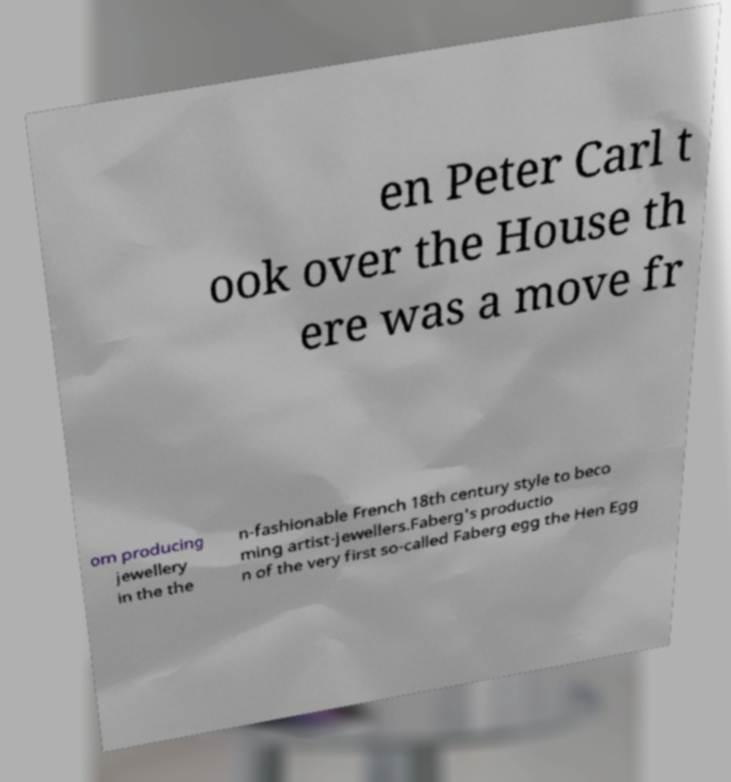What messages or text are displayed in this image? I need them in a readable, typed format. en Peter Carl t ook over the House th ere was a move fr om producing jewellery in the the n-fashionable French 18th century style to beco ming artist-jewellers.Faberg's productio n of the very first so-called Faberg egg the Hen Egg 